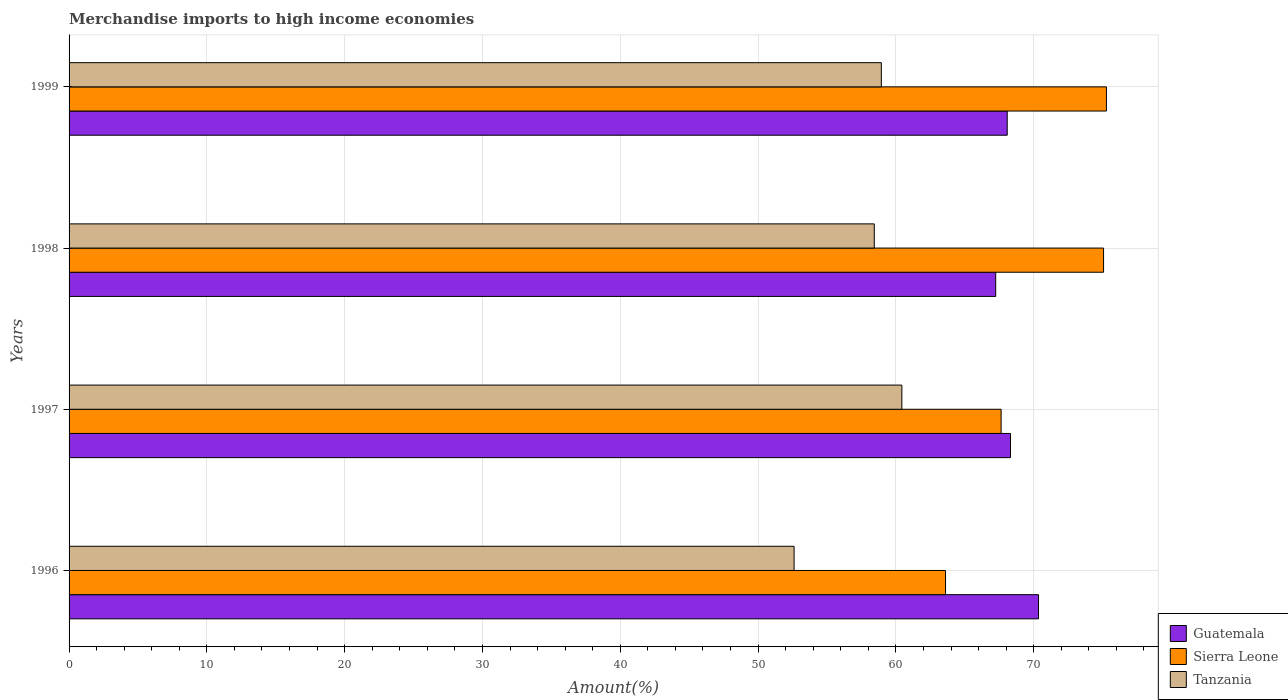How many groups of bars are there?
Provide a succinct answer. 4. How many bars are there on the 2nd tick from the bottom?
Your response must be concise. 3. In how many cases, is the number of bars for a given year not equal to the number of legend labels?
Make the answer very short. 0. What is the percentage of amount earned from merchandise imports in Sierra Leone in 1998?
Your answer should be compact. 75.07. Across all years, what is the maximum percentage of amount earned from merchandise imports in Tanzania?
Your response must be concise. 60.43. Across all years, what is the minimum percentage of amount earned from merchandise imports in Guatemala?
Make the answer very short. 67.24. In which year was the percentage of amount earned from merchandise imports in Guatemala maximum?
Offer a terse response. 1996. What is the total percentage of amount earned from merchandise imports in Guatemala in the graph?
Make the answer very short. 273.99. What is the difference between the percentage of amount earned from merchandise imports in Sierra Leone in 1996 and that in 1999?
Your answer should be very brief. -11.68. What is the difference between the percentage of amount earned from merchandise imports in Guatemala in 1997 and the percentage of amount earned from merchandise imports in Sierra Leone in 1999?
Provide a short and direct response. -6.96. What is the average percentage of amount earned from merchandise imports in Guatemala per year?
Give a very brief answer. 68.5. In the year 1997, what is the difference between the percentage of amount earned from merchandise imports in Tanzania and percentage of amount earned from merchandise imports in Sierra Leone?
Your response must be concise. -7.2. What is the ratio of the percentage of amount earned from merchandise imports in Tanzania in 1998 to that in 1999?
Ensure brevity in your answer.  0.99. Is the percentage of amount earned from merchandise imports in Tanzania in 1997 less than that in 1999?
Offer a terse response. No. What is the difference between the highest and the second highest percentage of amount earned from merchandise imports in Sierra Leone?
Ensure brevity in your answer.  0.21. What is the difference between the highest and the lowest percentage of amount earned from merchandise imports in Tanzania?
Provide a short and direct response. 7.82. In how many years, is the percentage of amount earned from merchandise imports in Guatemala greater than the average percentage of amount earned from merchandise imports in Guatemala taken over all years?
Your answer should be very brief. 1. What does the 1st bar from the top in 1998 represents?
Your answer should be compact. Tanzania. What does the 3rd bar from the bottom in 1998 represents?
Offer a very short reply. Tanzania. Is it the case that in every year, the sum of the percentage of amount earned from merchandise imports in Tanzania and percentage of amount earned from merchandise imports in Sierra Leone is greater than the percentage of amount earned from merchandise imports in Guatemala?
Make the answer very short. Yes. How many bars are there?
Your answer should be compact. 12. What is the difference between two consecutive major ticks on the X-axis?
Give a very brief answer. 10. Are the values on the major ticks of X-axis written in scientific E-notation?
Provide a succinct answer. No. Does the graph contain any zero values?
Offer a very short reply. No. Does the graph contain grids?
Give a very brief answer. Yes. Where does the legend appear in the graph?
Offer a very short reply. Bottom right. What is the title of the graph?
Provide a succinct answer. Merchandise imports to high income economies. What is the label or title of the X-axis?
Your answer should be very brief. Amount(%). What is the Amount(%) in Guatemala in 1996?
Ensure brevity in your answer.  70.35. What is the Amount(%) in Sierra Leone in 1996?
Ensure brevity in your answer.  63.6. What is the Amount(%) of Tanzania in 1996?
Offer a very short reply. 52.61. What is the Amount(%) in Guatemala in 1997?
Your answer should be very brief. 68.32. What is the Amount(%) of Sierra Leone in 1997?
Your answer should be very brief. 67.64. What is the Amount(%) in Tanzania in 1997?
Make the answer very short. 60.43. What is the Amount(%) in Guatemala in 1998?
Ensure brevity in your answer.  67.24. What is the Amount(%) of Sierra Leone in 1998?
Your answer should be very brief. 75.07. What is the Amount(%) of Tanzania in 1998?
Your answer should be compact. 58.43. What is the Amount(%) of Guatemala in 1999?
Your answer should be very brief. 68.08. What is the Amount(%) in Sierra Leone in 1999?
Give a very brief answer. 75.28. What is the Amount(%) of Tanzania in 1999?
Your answer should be compact. 58.94. Across all years, what is the maximum Amount(%) in Guatemala?
Make the answer very short. 70.35. Across all years, what is the maximum Amount(%) in Sierra Leone?
Your answer should be compact. 75.28. Across all years, what is the maximum Amount(%) in Tanzania?
Ensure brevity in your answer.  60.43. Across all years, what is the minimum Amount(%) in Guatemala?
Offer a very short reply. 67.24. Across all years, what is the minimum Amount(%) of Sierra Leone?
Make the answer very short. 63.6. Across all years, what is the minimum Amount(%) of Tanzania?
Your response must be concise. 52.61. What is the total Amount(%) of Guatemala in the graph?
Give a very brief answer. 273.99. What is the total Amount(%) of Sierra Leone in the graph?
Ensure brevity in your answer.  281.59. What is the total Amount(%) in Tanzania in the graph?
Ensure brevity in your answer.  230.43. What is the difference between the Amount(%) of Guatemala in 1996 and that in 1997?
Make the answer very short. 2.03. What is the difference between the Amount(%) of Sierra Leone in 1996 and that in 1997?
Provide a short and direct response. -4.03. What is the difference between the Amount(%) in Tanzania in 1996 and that in 1997?
Offer a very short reply. -7.82. What is the difference between the Amount(%) in Guatemala in 1996 and that in 1998?
Ensure brevity in your answer.  3.11. What is the difference between the Amount(%) of Sierra Leone in 1996 and that in 1998?
Offer a terse response. -11.47. What is the difference between the Amount(%) of Tanzania in 1996 and that in 1998?
Give a very brief answer. -5.82. What is the difference between the Amount(%) in Guatemala in 1996 and that in 1999?
Provide a succinct answer. 2.27. What is the difference between the Amount(%) of Sierra Leone in 1996 and that in 1999?
Provide a succinct answer. -11.68. What is the difference between the Amount(%) in Tanzania in 1996 and that in 1999?
Provide a succinct answer. -6.33. What is the difference between the Amount(%) of Guatemala in 1997 and that in 1998?
Make the answer very short. 1.07. What is the difference between the Amount(%) in Sierra Leone in 1997 and that in 1998?
Offer a very short reply. -7.44. What is the difference between the Amount(%) of Tanzania in 1997 and that in 1998?
Your answer should be compact. 2. What is the difference between the Amount(%) in Guatemala in 1997 and that in 1999?
Your answer should be compact. 0.24. What is the difference between the Amount(%) of Sierra Leone in 1997 and that in 1999?
Keep it short and to the point. -7.64. What is the difference between the Amount(%) of Tanzania in 1997 and that in 1999?
Keep it short and to the point. 1.49. What is the difference between the Amount(%) of Guatemala in 1998 and that in 1999?
Your answer should be very brief. -0.84. What is the difference between the Amount(%) of Sierra Leone in 1998 and that in 1999?
Keep it short and to the point. -0.21. What is the difference between the Amount(%) of Tanzania in 1998 and that in 1999?
Provide a short and direct response. -0.51. What is the difference between the Amount(%) in Guatemala in 1996 and the Amount(%) in Sierra Leone in 1997?
Make the answer very short. 2.71. What is the difference between the Amount(%) in Guatemala in 1996 and the Amount(%) in Tanzania in 1997?
Your answer should be compact. 9.92. What is the difference between the Amount(%) in Sierra Leone in 1996 and the Amount(%) in Tanzania in 1997?
Give a very brief answer. 3.17. What is the difference between the Amount(%) of Guatemala in 1996 and the Amount(%) of Sierra Leone in 1998?
Provide a succinct answer. -4.72. What is the difference between the Amount(%) of Guatemala in 1996 and the Amount(%) of Tanzania in 1998?
Provide a succinct answer. 11.92. What is the difference between the Amount(%) in Sierra Leone in 1996 and the Amount(%) in Tanzania in 1998?
Your answer should be compact. 5.17. What is the difference between the Amount(%) of Guatemala in 1996 and the Amount(%) of Sierra Leone in 1999?
Your response must be concise. -4.93. What is the difference between the Amount(%) in Guatemala in 1996 and the Amount(%) in Tanzania in 1999?
Your response must be concise. 11.41. What is the difference between the Amount(%) of Sierra Leone in 1996 and the Amount(%) of Tanzania in 1999?
Your response must be concise. 4.66. What is the difference between the Amount(%) of Guatemala in 1997 and the Amount(%) of Sierra Leone in 1998?
Provide a short and direct response. -6.76. What is the difference between the Amount(%) of Guatemala in 1997 and the Amount(%) of Tanzania in 1998?
Give a very brief answer. 9.88. What is the difference between the Amount(%) of Sierra Leone in 1997 and the Amount(%) of Tanzania in 1998?
Your answer should be compact. 9.2. What is the difference between the Amount(%) of Guatemala in 1997 and the Amount(%) of Sierra Leone in 1999?
Provide a short and direct response. -6.96. What is the difference between the Amount(%) of Guatemala in 1997 and the Amount(%) of Tanzania in 1999?
Your response must be concise. 9.37. What is the difference between the Amount(%) of Sierra Leone in 1997 and the Amount(%) of Tanzania in 1999?
Provide a short and direct response. 8.69. What is the difference between the Amount(%) of Guatemala in 1998 and the Amount(%) of Sierra Leone in 1999?
Give a very brief answer. -8.04. What is the difference between the Amount(%) of Guatemala in 1998 and the Amount(%) of Tanzania in 1999?
Keep it short and to the point. 8.3. What is the difference between the Amount(%) in Sierra Leone in 1998 and the Amount(%) in Tanzania in 1999?
Provide a succinct answer. 16.13. What is the average Amount(%) of Guatemala per year?
Provide a short and direct response. 68.5. What is the average Amount(%) of Sierra Leone per year?
Keep it short and to the point. 70.4. What is the average Amount(%) in Tanzania per year?
Your answer should be compact. 57.61. In the year 1996, what is the difference between the Amount(%) in Guatemala and Amount(%) in Sierra Leone?
Your answer should be compact. 6.75. In the year 1996, what is the difference between the Amount(%) of Guatemala and Amount(%) of Tanzania?
Provide a succinct answer. 17.74. In the year 1996, what is the difference between the Amount(%) of Sierra Leone and Amount(%) of Tanzania?
Offer a very short reply. 10.99. In the year 1997, what is the difference between the Amount(%) of Guatemala and Amount(%) of Sierra Leone?
Keep it short and to the point. 0.68. In the year 1997, what is the difference between the Amount(%) of Guatemala and Amount(%) of Tanzania?
Your answer should be very brief. 7.88. In the year 1997, what is the difference between the Amount(%) in Sierra Leone and Amount(%) in Tanzania?
Give a very brief answer. 7.2. In the year 1998, what is the difference between the Amount(%) in Guatemala and Amount(%) in Sierra Leone?
Make the answer very short. -7.83. In the year 1998, what is the difference between the Amount(%) of Guatemala and Amount(%) of Tanzania?
Your answer should be compact. 8.81. In the year 1998, what is the difference between the Amount(%) of Sierra Leone and Amount(%) of Tanzania?
Offer a very short reply. 16.64. In the year 1999, what is the difference between the Amount(%) in Guatemala and Amount(%) in Sierra Leone?
Provide a short and direct response. -7.2. In the year 1999, what is the difference between the Amount(%) in Guatemala and Amount(%) in Tanzania?
Give a very brief answer. 9.14. In the year 1999, what is the difference between the Amount(%) in Sierra Leone and Amount(%) in Tanzania?
Provide a short and direct response. 16.34. What is the ratio of the Amount(%) of Guatemala in 1996 to that in 1997?
Keep it short and to the point. 1.03. What is the ratio of the Amount(%) of Sierra Leone in 1996 to that in 1997?
Provide a succinct answer. 0.94. What is the ratio of the Amount(%) in Tanzania in 1996 to that in 1997?
Give a very brief answer. 0.87. What is the ratio of the Amount(%) of Guatemala in 1996 to that in 1998?
Provide a succinct answer. 1.05. What is the ratio of the Amount(%) in Sierra Leone in 1996 to that in 1998?
Offer a terse response. 0.85. What is the ratio of the Amount(%) of Tanzania in 1996 to that in 1998?
Your answer should be very brief. 0.9. What is the ratio of the Amount(%) in Guatemala in 1996 to that in 1999?
Give a very brief answer. 1.03. What is the ratio of the Amount(%) in Sierra Leone in 1996 to that in 1999?
Your answer should be very brief. 0.84. What is the ratio of the Amount(%) of Tanzania in 1996 to that in 1999?
Your response must be concise. 0.89. What is the ratio of the Amount(%) in Guatemala in 1997 to that in 1998?
Keep it short and to the point. 1.02. What is the ratio of the Amount(%) of Sierra Leone in 1997 to that in 1998?
Offer a terse response. 0.9. What is the ratio of the Amount(%) of Tanzania in 1997 to that in 1998?
Make the answer very short. 1.03. What is the ratio of the Amount(%) of Guatemala in 1997 to that in 1999?
Your answer should be very brief. 1. What is the ratio of the Amount(%) of Sierra Leone in 1997 to that in 1999?
Give a very brief answer. 0.9. What is the ratio of the Amount(%) in Tanzania in 1997 to that in 1999?
Your response must be concise. 1.03. What is the ratio of the Amount(%) of Tanzania in 1998 to that in 1999?
Provide a succinct answer. 0.99. What is the difference between the highest and the second highest Amount(%) in Guatemala?
Your answer should be compact. 2.03. What is the difference between the highest and the second highest Amount(%) in Sierra Leone?
Make the answer very short. 0.21. What is the difference between the highest and the second highest Amount(%) in Tanzania?
Your response must be concise. 1.49. What is the difference between the highest and the lowest Amount(%) of Guatemala?
Keep it short and to the point. 3.11. What is the difference between the highest and the lowest Amount(%) of Sierra Leone?
Provide a short and direct response. 11.68. What is the difference between the highest and the lowest Amount(%) of Tanzania?
Keep it short and to the point. 7.82. 